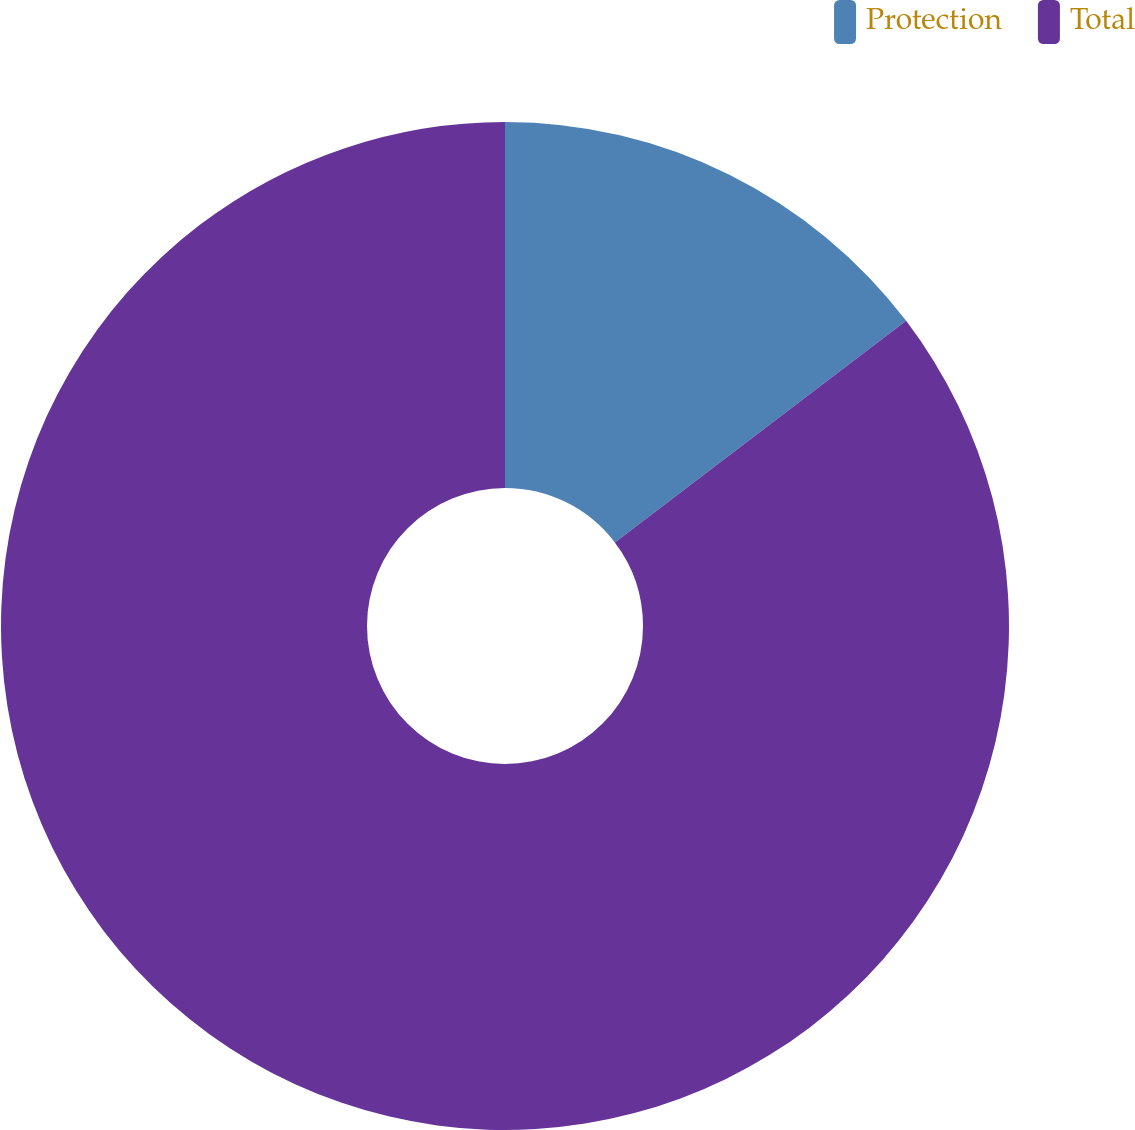Convert chart to OTSL. <chart><loc_0><loc_0><loc_500><loc_500><pie_chart><fcel>Protection<fcel>Total<nl><fcel>14.65%<fcel>85.35%<nl></chart> 